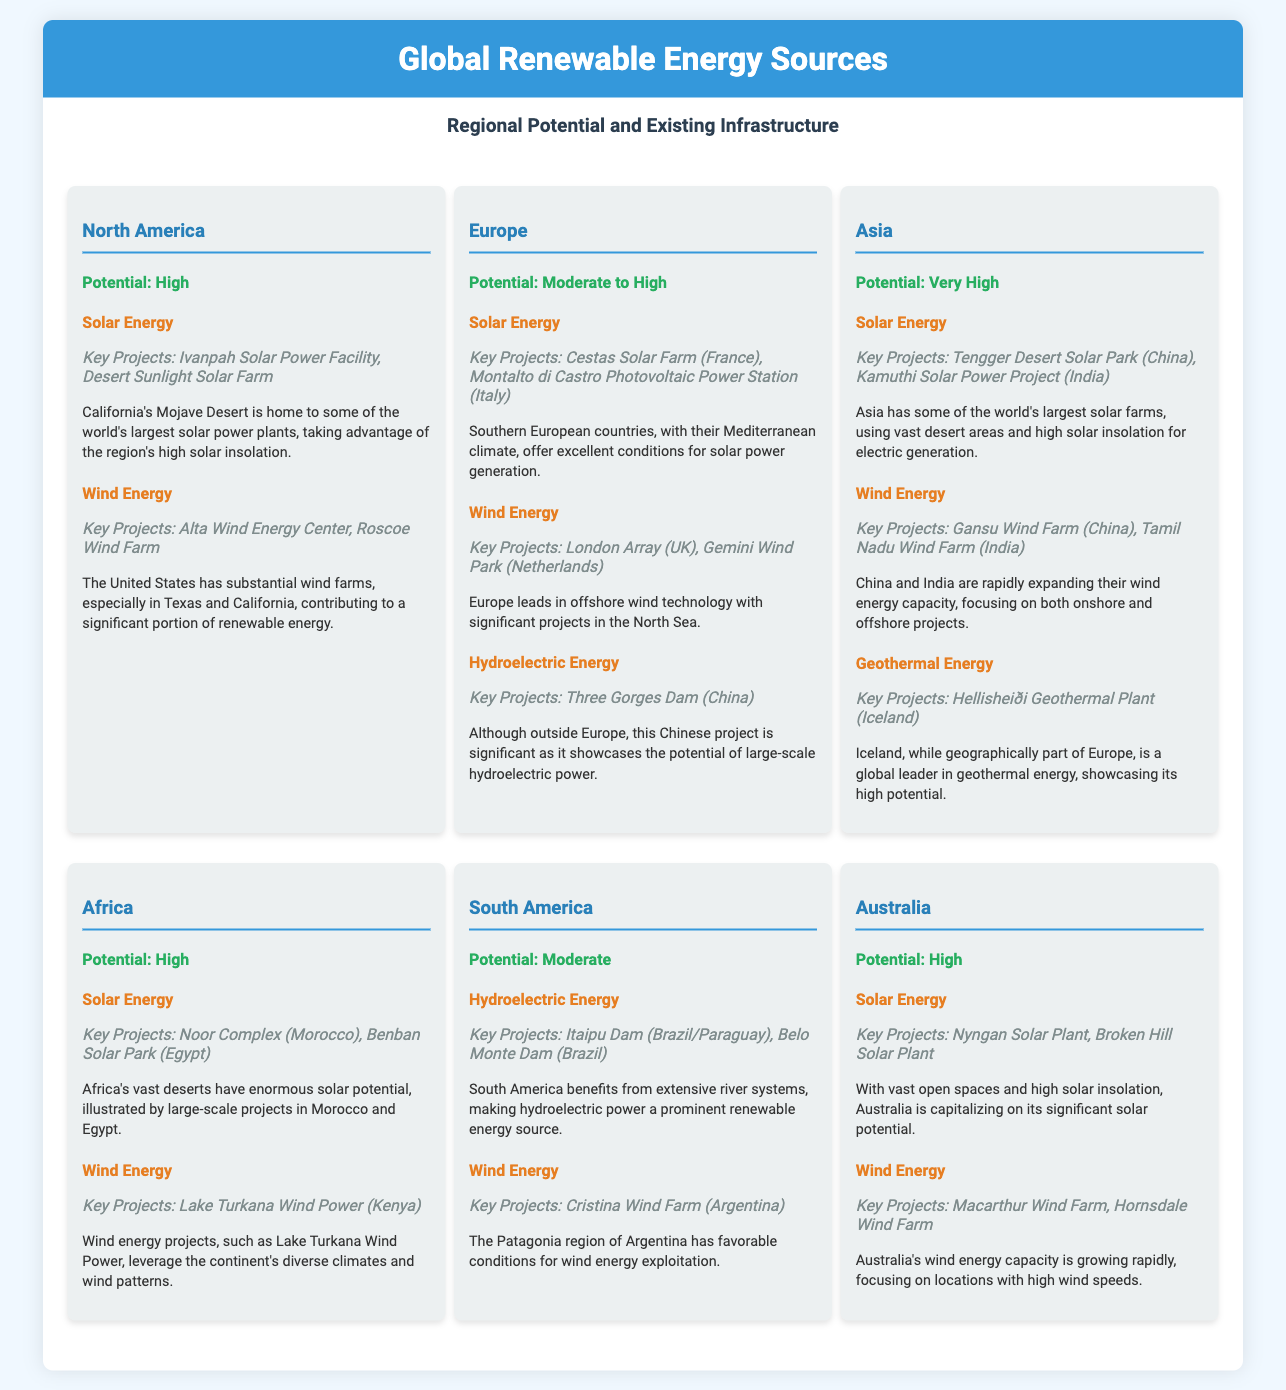What is the renewable energy potential for Asia? Asia has a potential described as "Very High" in the document.
Answer: Very High Which country has the key solar project "Noor Complex"? The "Noor Complex" is mentioned as a key project in Morocco.
Answer: Morocco What is a key wind energy project in North America? The document lists "Roscoe Wind Farm" as a significant wind energy project in North America.
Answer: Roscoe Wind Farm How many energy types are listed for Africa? The document specifies two energy types for Africa: Solar Energy and Wind Energy.
Answer: 2 What is the potential of South America for renewable energy? South America is noted to have "Moderate" potential for renewable energy.
Answer: Moderate Which region leads in offshore wind technology? The document indicates that Europe leads in offshore wind technology.
Answer: Europe Name a key geothermal energy project mentioned in the document. "Hellisheiði Geothermal Plant" (Iceland) is identified as a key geothermal energy project.
Answer: Hellisheiði Geothermal Plant What is a significant hydroelectric energy project in South America? The document highlights "Itaipu Dam" as a significant hydroelectric project in South America.
Answer: Itaipu Dam What type of renewable energy has a key project called "Gansu Wind Farm"? "Gansu Wind Farm" is associated with wind energy in the document.
Answer: Wind Energy 